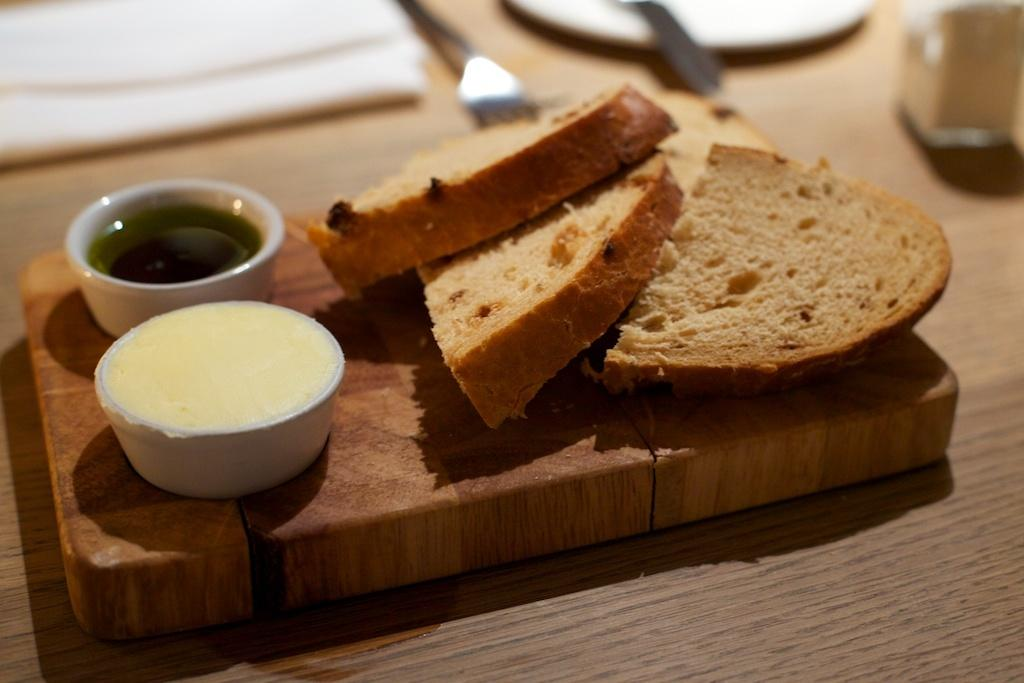What object is the main focus of the image? There is a serving tray in the image. What is placed on the serving tray? The serving tray has slices of bread and two bowls of dips. What type of comb is used to start the milk in the image? There is no comb or milk present in the image. 